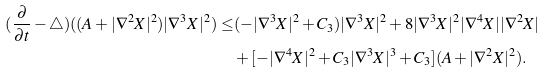Convert formula to latex. <formula><loc_0><loc_0><loc_500><loc_500>( \frac { \partial } { \partial t } - { \triangle } ) ( ( A + | { \nabla ^ { 2 } } { X } | ^ { 2 } ) | { \nabla ^ { 3 } } { X } | ^ { 2 } ) \leq & ( - | { \nabla ^ { 3 } } { X } | ^ { 2 } + C _ { 3 } ) | { \nabla ^ { 3 } } { X } | ^ { 2 } + 8 | { \nabla ^ { 3 } } { X } | ^ { 2 } | { \nabla ^ { 4 } } { X } | | { \nabla ^ { 2 } } { X } | \\ & + [ - | { \nabla ^ { 4 } } { X } | ^ { 2 } + C _ { 3 } | { \nabla ^ { 3 } } { X } | ^ { 3 } + C _ { 3 } ] ( A + | { \nabla ^ { 2 } } { X } | ^ { 2 } ) .</formula> 